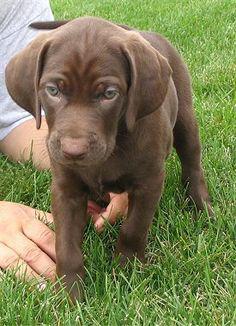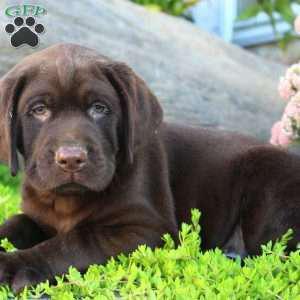The first image is the image on the left, the second image is the image on the right. Evaluate the accuracy of this statement regarding the images: "A dog appears to be lying down.". Is it true? Answer yes or no. Yes. The first image is the image on the left, the second image is the image on the right. Given the left and right images, does the statement "There's one black lab and one chocolate lab." hold true? Answer yes or no. No. 